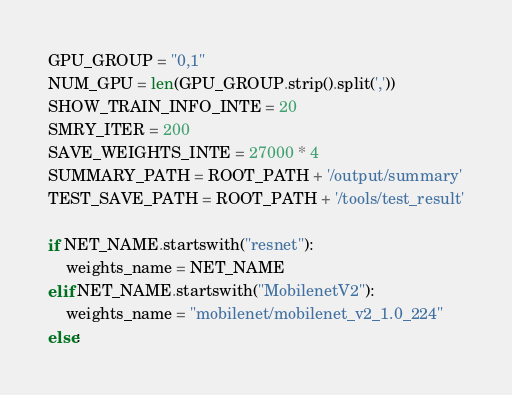Convert code to text. <code><loc_0><loc_0><loc_500><loc_500><_Python_>GPU_GROUP = "0,1"
NUM_GPU = len(GPU_GROUP.strip().split(','))
SHOW_TRAIN_INFO_INTE = 20
SMRY_ITER = 200
SAVE_WEIGHTS_INTE = 27000 * 4
SUMMARY_PATH = ROOT_PATH + '/output/summary'
TEST_SAVE_PATH = ROOT_PATH + '/tools/test_result'

if NET_NAME.startswith("resnet"):
    weights_name = NET_NAME
elif NET_NAME.startswith("MobilenetV2"):
    weights_name = "mobilenet/mobilenet_v2_1.0_224"
else:</code> 